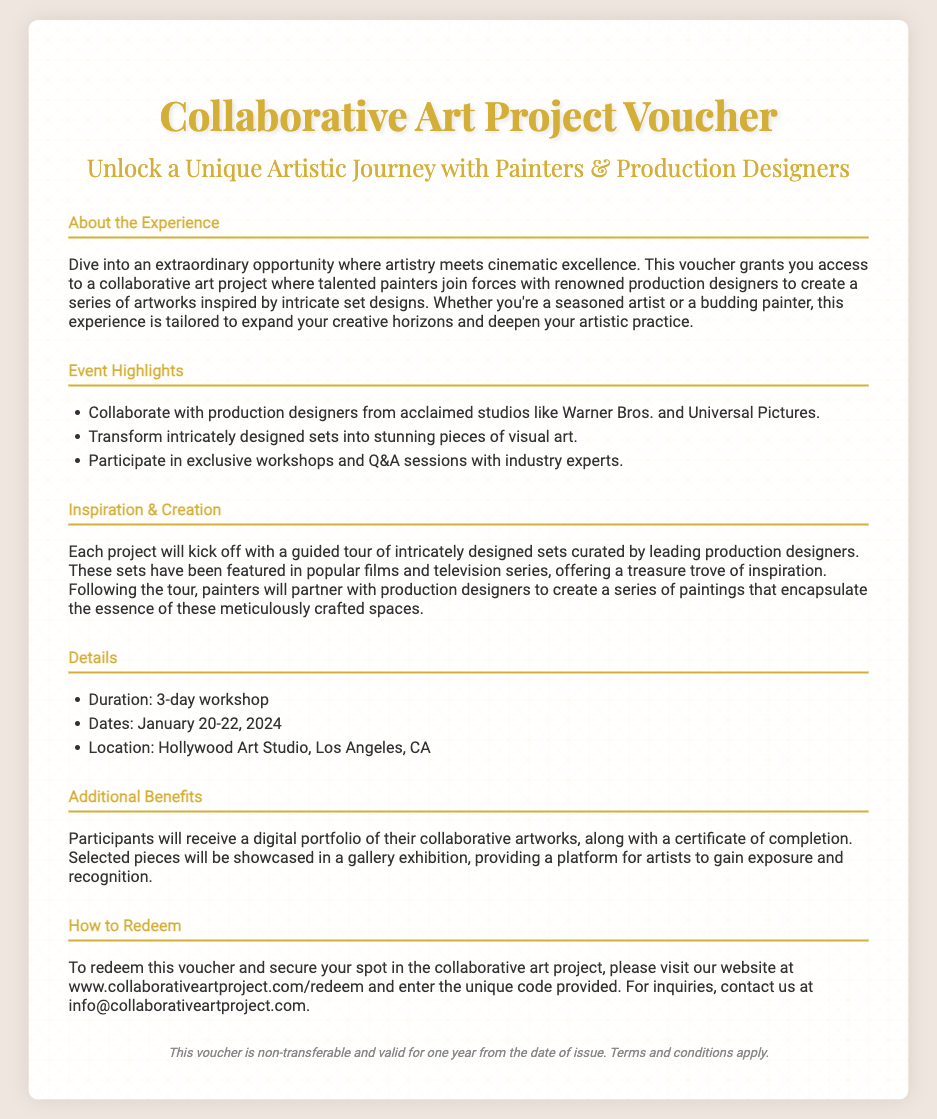what is the title of the experience? The title of the experience is featured prominently at the top of the document.
Answer: Collaborative Art Project Voucher who can you collaborate with during the project? The document mentions that participants can collaborate with production designers from acclaimed studios.
Answer: production designers what are the dates for the workshop? The specific dates for the workshop are mentioned in the details section.
Answer: January 20-22, 2024 how long is the workshop? The duration of the workshop is clearly stated in the details section.
Answer: 3-day workshop what benefits do participants receive? The document lists specific benefits that participants will receive upon completion.
Answer: digital portfolio and certificate of completion what can participants expect to create? The document describes the main output of the collaborative experience involving participants.
Answer: series of paintings where is the workshop located? The location of the workshop is provided in the details section.
Answer: Hollywood Art Studio, Los Angeles, CA how do you redeem the voucher? The document explains the process for redeeming the voucher.
Answer: visit the website is the voucher transferable? The footer of the document includes terms regarding the voucher's transferability.
Answer: non-transferable 